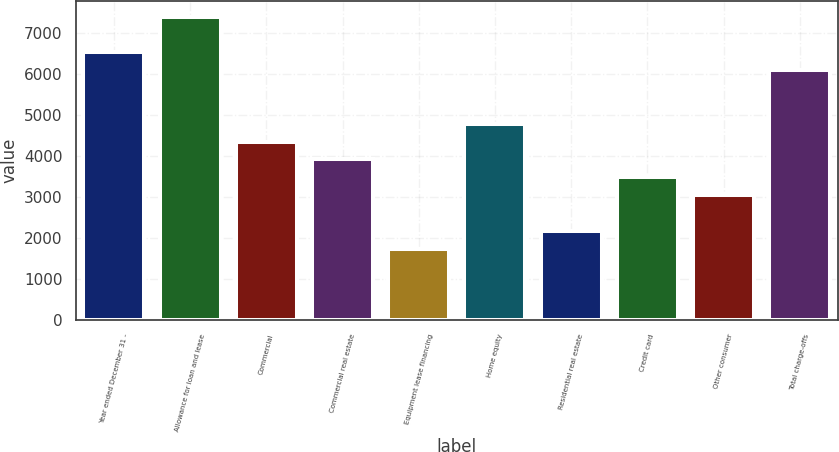<chart> <loc_0><loc_0><loc_500><loc_500><bar_chart><fcel>Year ended December 31 -<fcel>Allowance for loan and lease<fcel>Commercial<fcel>Commercial real estate<fcel>Equipment lease financing<fcel>Home equity<fcel>Residential real estate<fcel>Credit card<fcel>Other consumer<fcel>Total charge-offs<nl><fcel>6520.16<fcel>7389.44<fcel>4346.96<fcel>3912.32<fcel>1739.12<fcel>4781.6<fcel>2173.76<fcel>3477.68<fcel>3043.04<fcel>6085.52<nl></chart> 